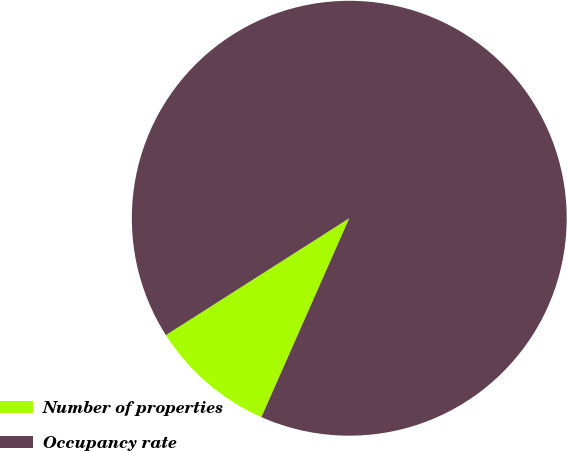Convert chart to OTSL. <chart><loc_0><loc_0><loc_500><loc_500><pie_chart><fcel>Number of properties<fcel>Occupancy rate<nl><fcel>9.35%<fcel>90.65%<nl></chart> 